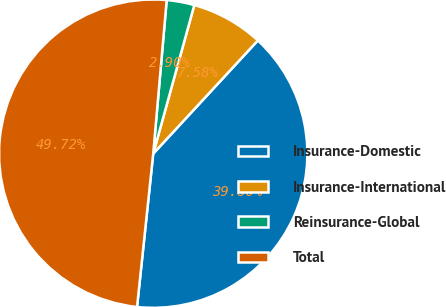Convert chart to OTSL. <chart><loc_0><loc_0><loc_500><loc_500><pie_chart><fcel>Insurance-Domestic<fcel>Insurance-International<fcel>Reinsurance-Global<fcel>Total<nl><fcel>39.8%<fcel>7.58%<fcel>2.9%<fcel>49.72%<nl></chart> 